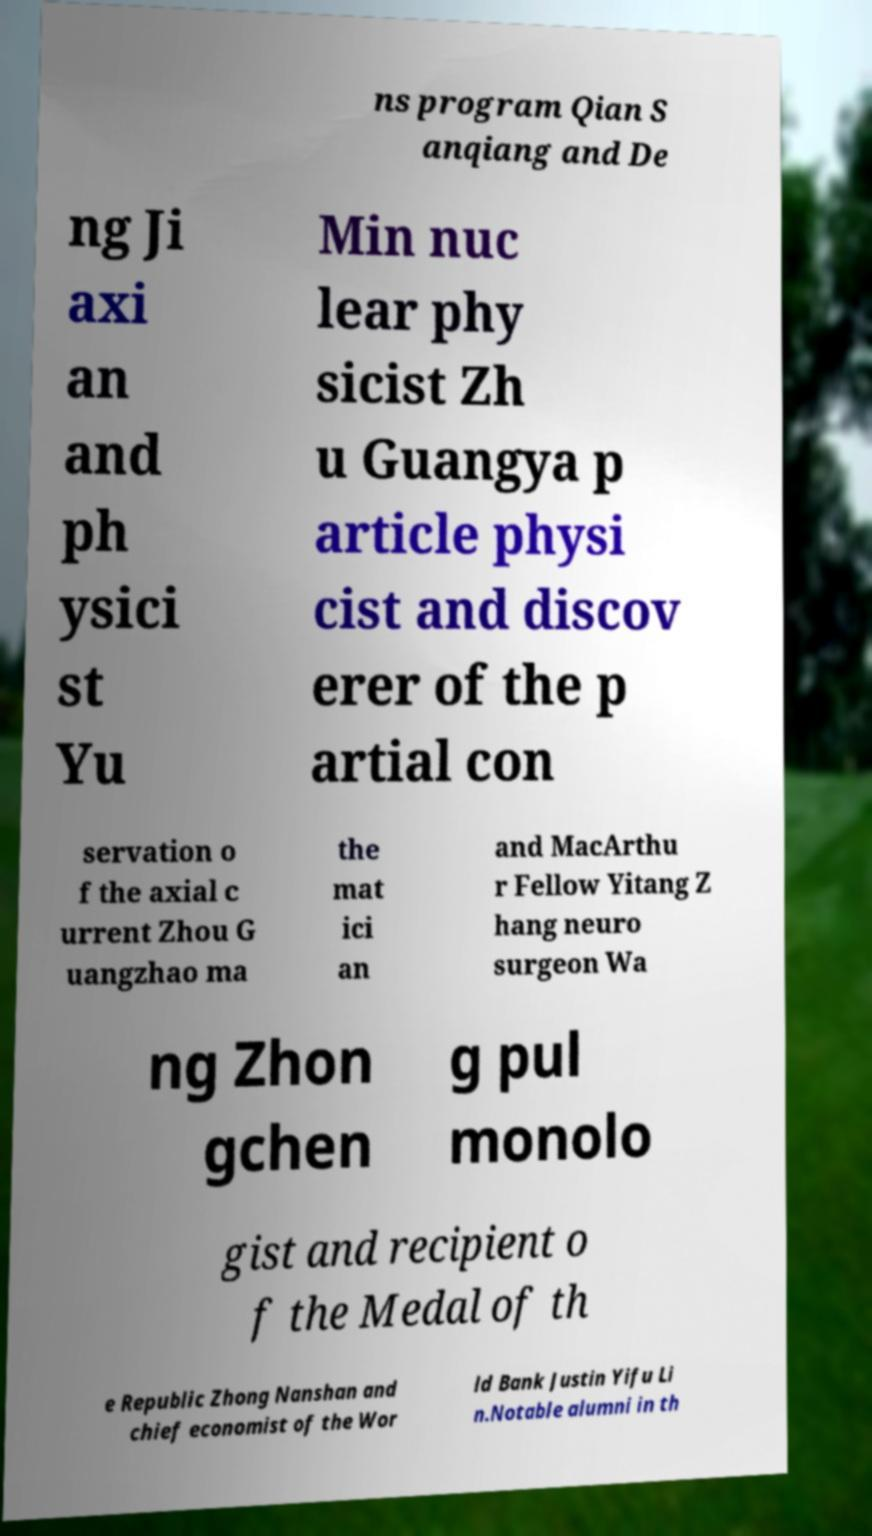Could you extract and type out the text from this image? ns program Qian S anqiang and De ng Ji axi an and ph ysici st Yu Min nuc lear phy sicist Zh u Guangya p article physi cist and discov erer of the p artial con servation o f the axial c urrent Zhou G uangzhao ma the mat ici an and MacArthu r Fellow Yitang Z hang neuro surgeon Wa ng Zhon gchen g pul monolo gist and recipient o f the Medal of th e Republic Zhong Nanshan and chief economist of the Wor ld Bank Justin Yifu Li n.Notable alumni in th 